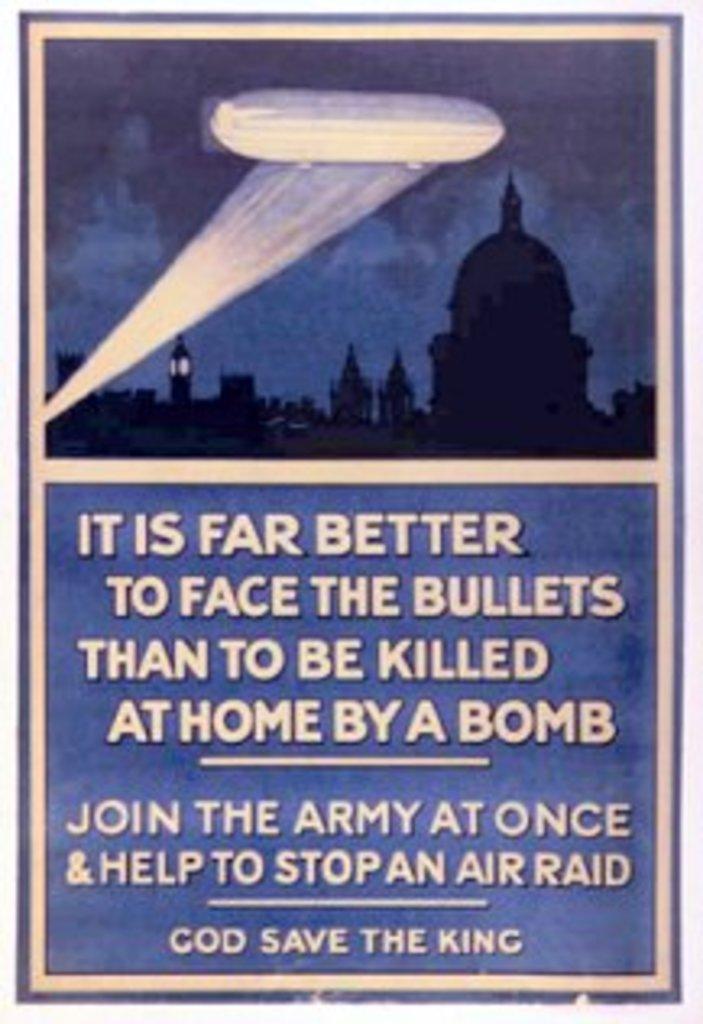What is it far better to do?
Provide a short and direct response. Face the bullets. What does this want you to join?
Provide a short and direct response. Army. 